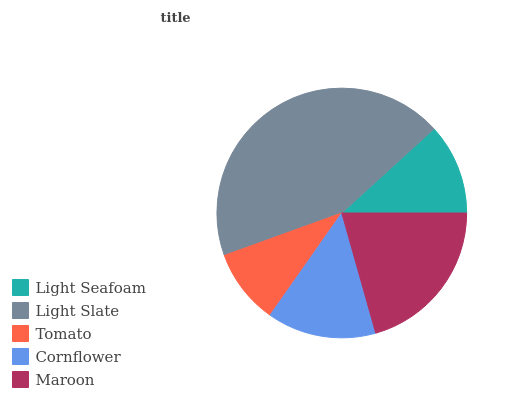Is Tomato the minimum?
Answer yes or no. Yes. Is Light Slate the maximum?
Answer yes or no. Yes. Is Light Slate the minimum?
Answer yes or no. No. Is Tomato the maximum?
Answer yes or no. No. Is Light Slate greater than Tomato?
Answer yes or no. Yes. Is Tomato less than Light Slate?
Answer yes or no. Yes. Is Tomato greater than Light Slate?
Answer yes or no. No. Is Light Slate less than Tomato?
Answer yes or no. No. Is Cornflower the high median?
Answer yes or no. Yes. Is Cornflower the low median?
Answer yes or no. Yes. Is Light Slate the high median?
Answer yes or no. No. Is Light Seafoam the low median?
Answer yes or no. No. 